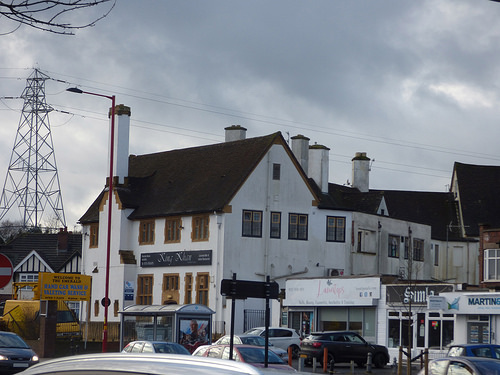<image>
Is there a pole behind the building? No. The pole is not behind the building. From this viewpoint, the pole appears to be positioned elsewhere in the scene. 